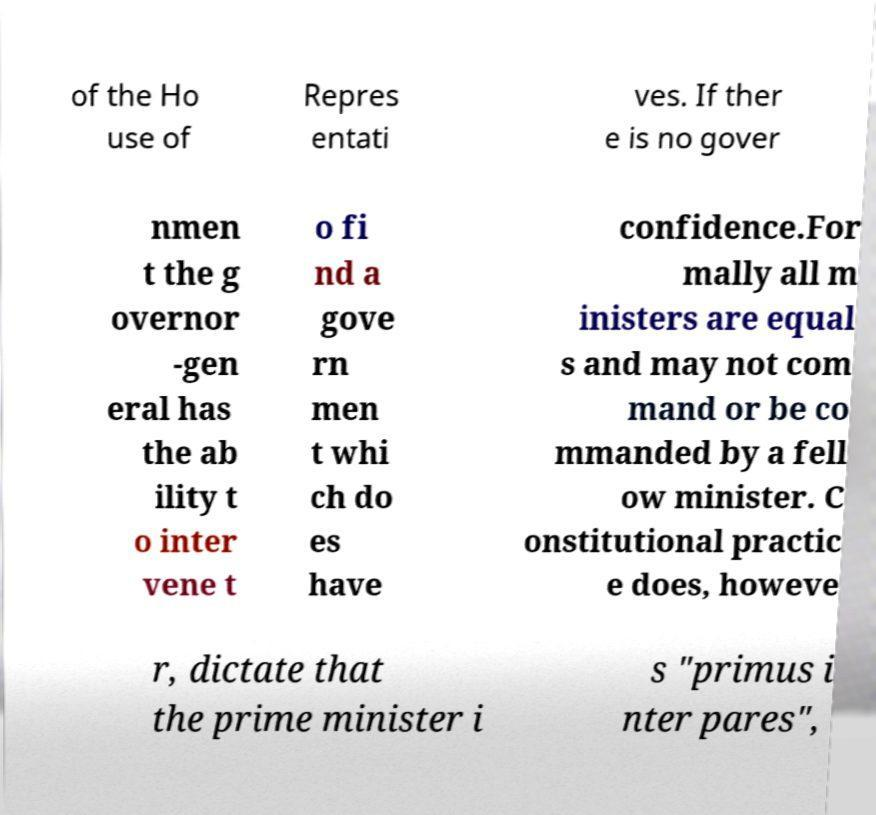Please identify and transcribe the text found in this image. of the Ho use of Repres entati ves. If ther e is no gover nmen t the g overnor -gen eral has the ab ility t o inter vene t o fi nd a gove rn men t whi ch do es have confidence.For mally all m inisters are equal s and may not com mand or be co mmanded by a fell ow minister. C onstitutional practic e does, howeve r, dictate that the prime minister i s "primus i nter pares", 